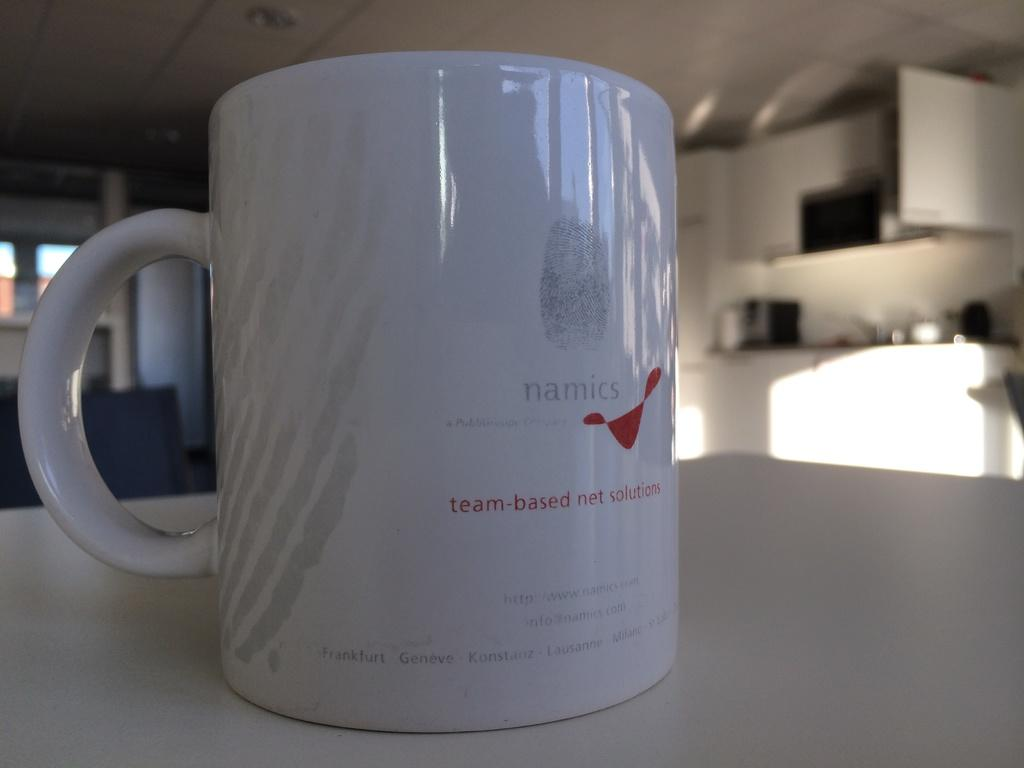<image>
Relay a brief, clear account of the picture shown. A white coffee mug with namics written on it. 